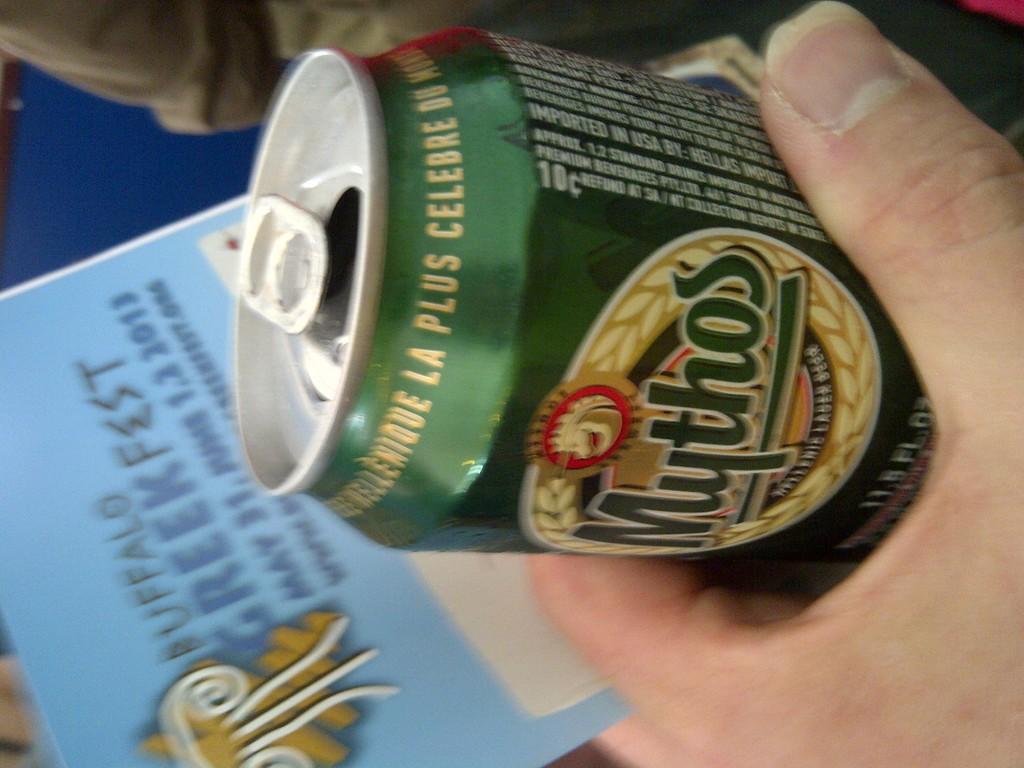What brand of beer is the person holding?
Offer a very short reply. Mythos. How many fluid ounces does the can hold?
Provide a succinct answer. 11.5. 